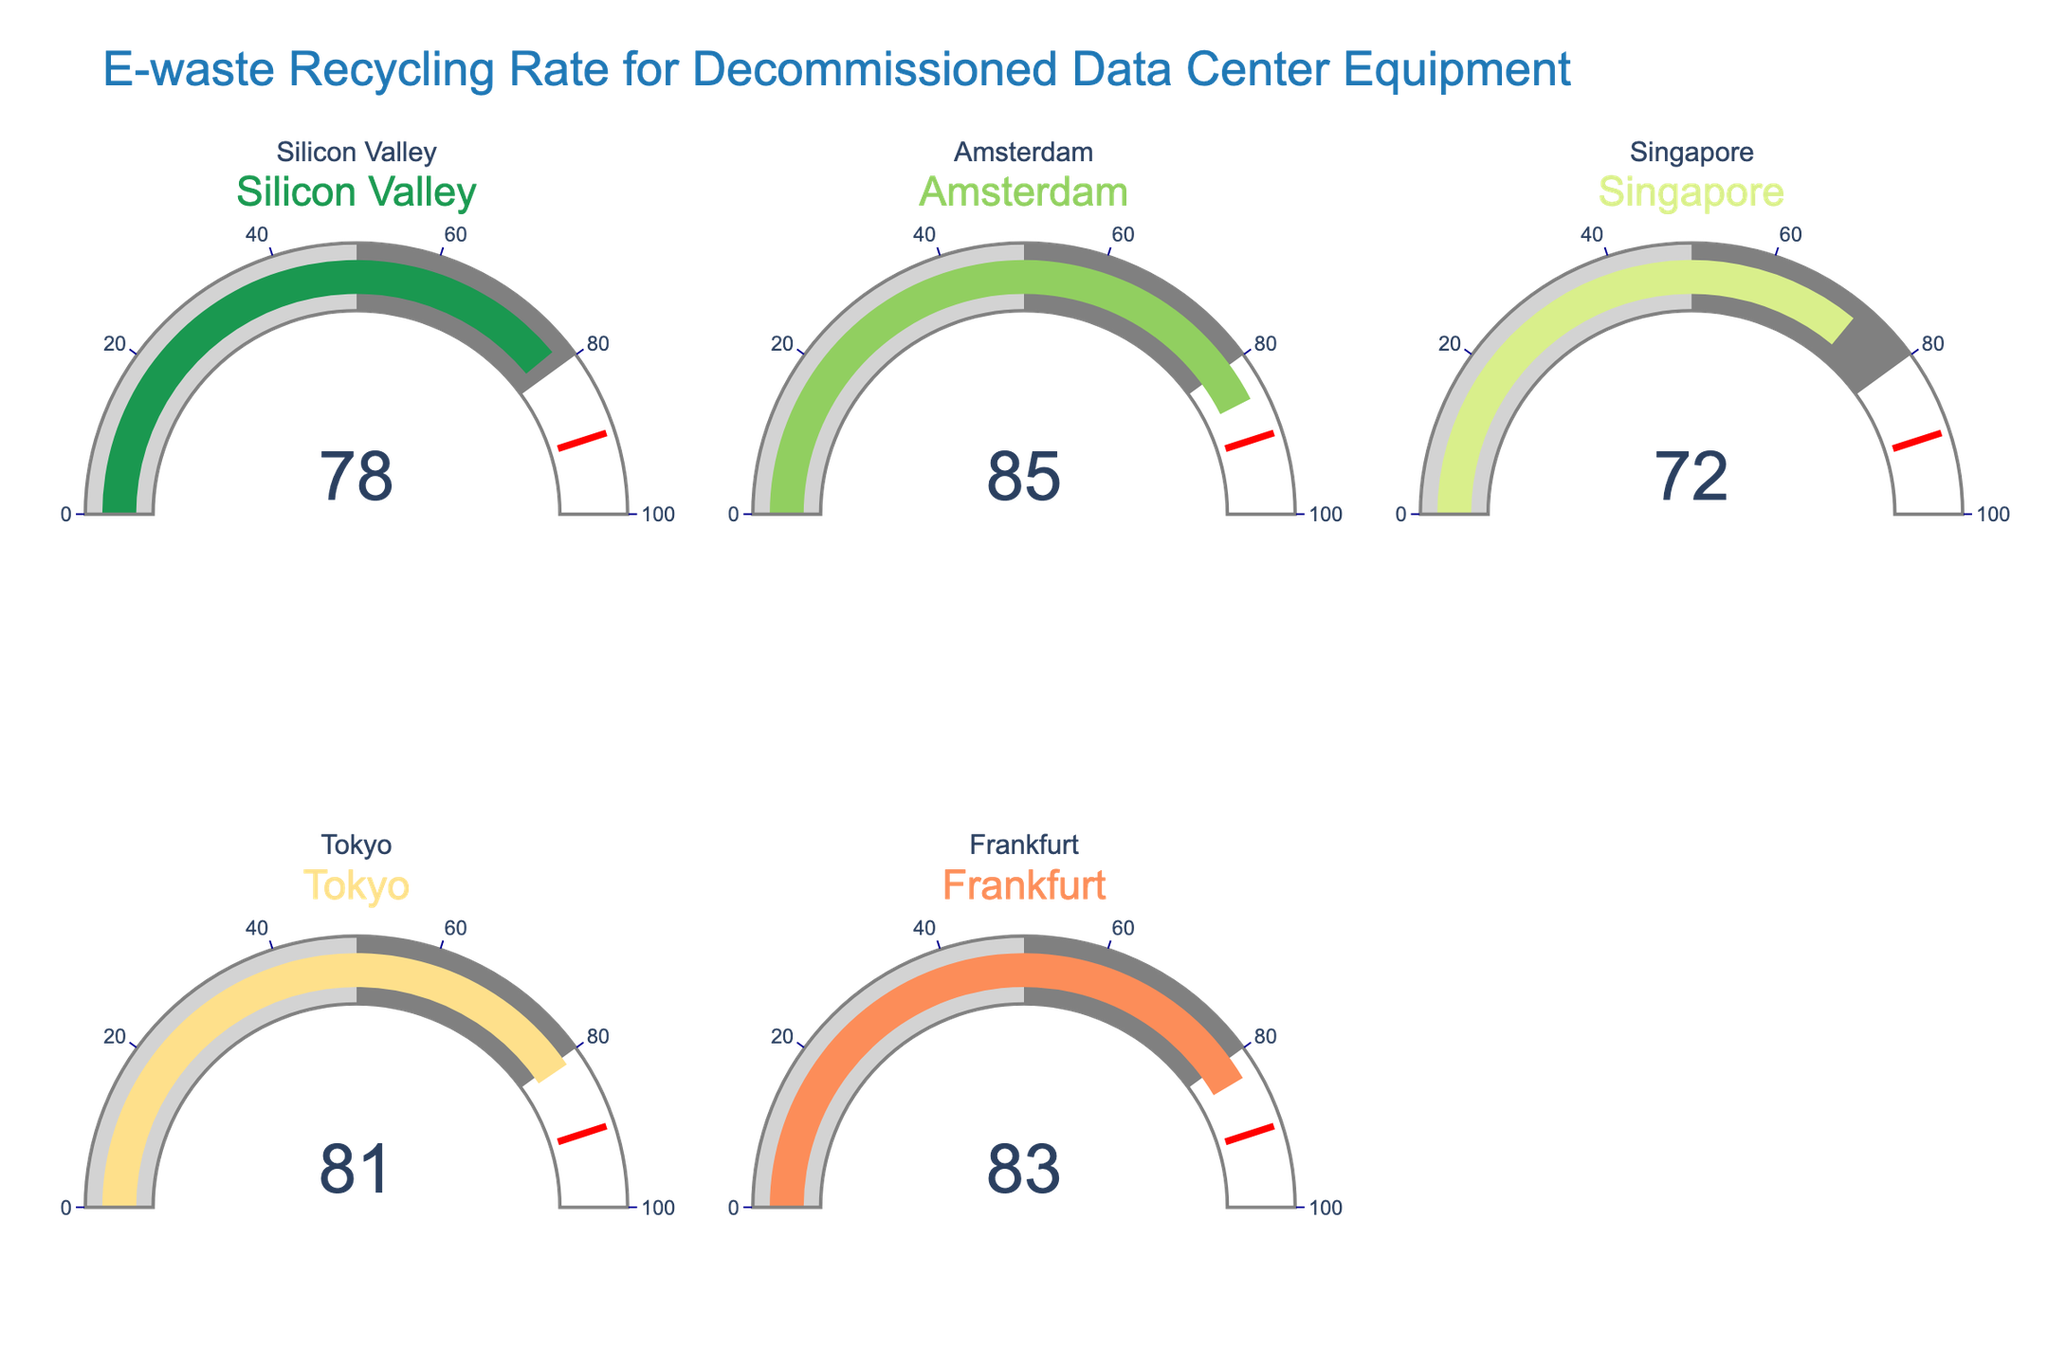What's the E-waste recycling rate for Silicon Valley? The gauge for Silicon Valley shows a single number which represents the E-waste recycling rate.
Answer: 78 Which location has the highest E-waste recycling rate? By comparing all the gauge values, Amsterdam has the highest value.
Answer: Amsterdam What's the difference in E-waste recycling rates between Silicon Valley and Singapore? Subtract the value for Singapore from that of Silicon Valley: 78 - 72 = 6
Answer: 6 How many locations have an E-waste recycling rate above 80? Count the gauges with values above 80: Amsterdam, Tokyo, and Frankfurt, which are 3 locations.
Answer: 3 What’s the average E-waste recycling rate of all locations? Sum all the recycling rates and divide by the number of locations: (78 + 85 + 72 + 81 + 83) / 5 = 79.8
Answer: 79.8 Is the E-waste recycling rate for Frankfurt greater than that of Tokyo? Compare the values directly: Frankfurt (83) is less than Tokyo (81).
Answer: No Which location has the lowest E-waste recycling rate? By identifying the lowest value among the gauges, Singapore has the lowest rate.
Answer: Singapore What range of values do the gauges display? The minimum gauge value is for Singapore (72) and the maximum is for Amsterdam (85).
Answer: 72 to 85 Are the E-waste recycling rates consistent across all locations? By observing the ranges and differences in values, there is some variation but all values are relatively close to each other.
Answer: No What is the threshold value indicated on the gauge charts, and does any location reach it? The threshold value marked on the gauge charts is 90, and no location's rate meets or exceeds this value.
Answer: 90, No 